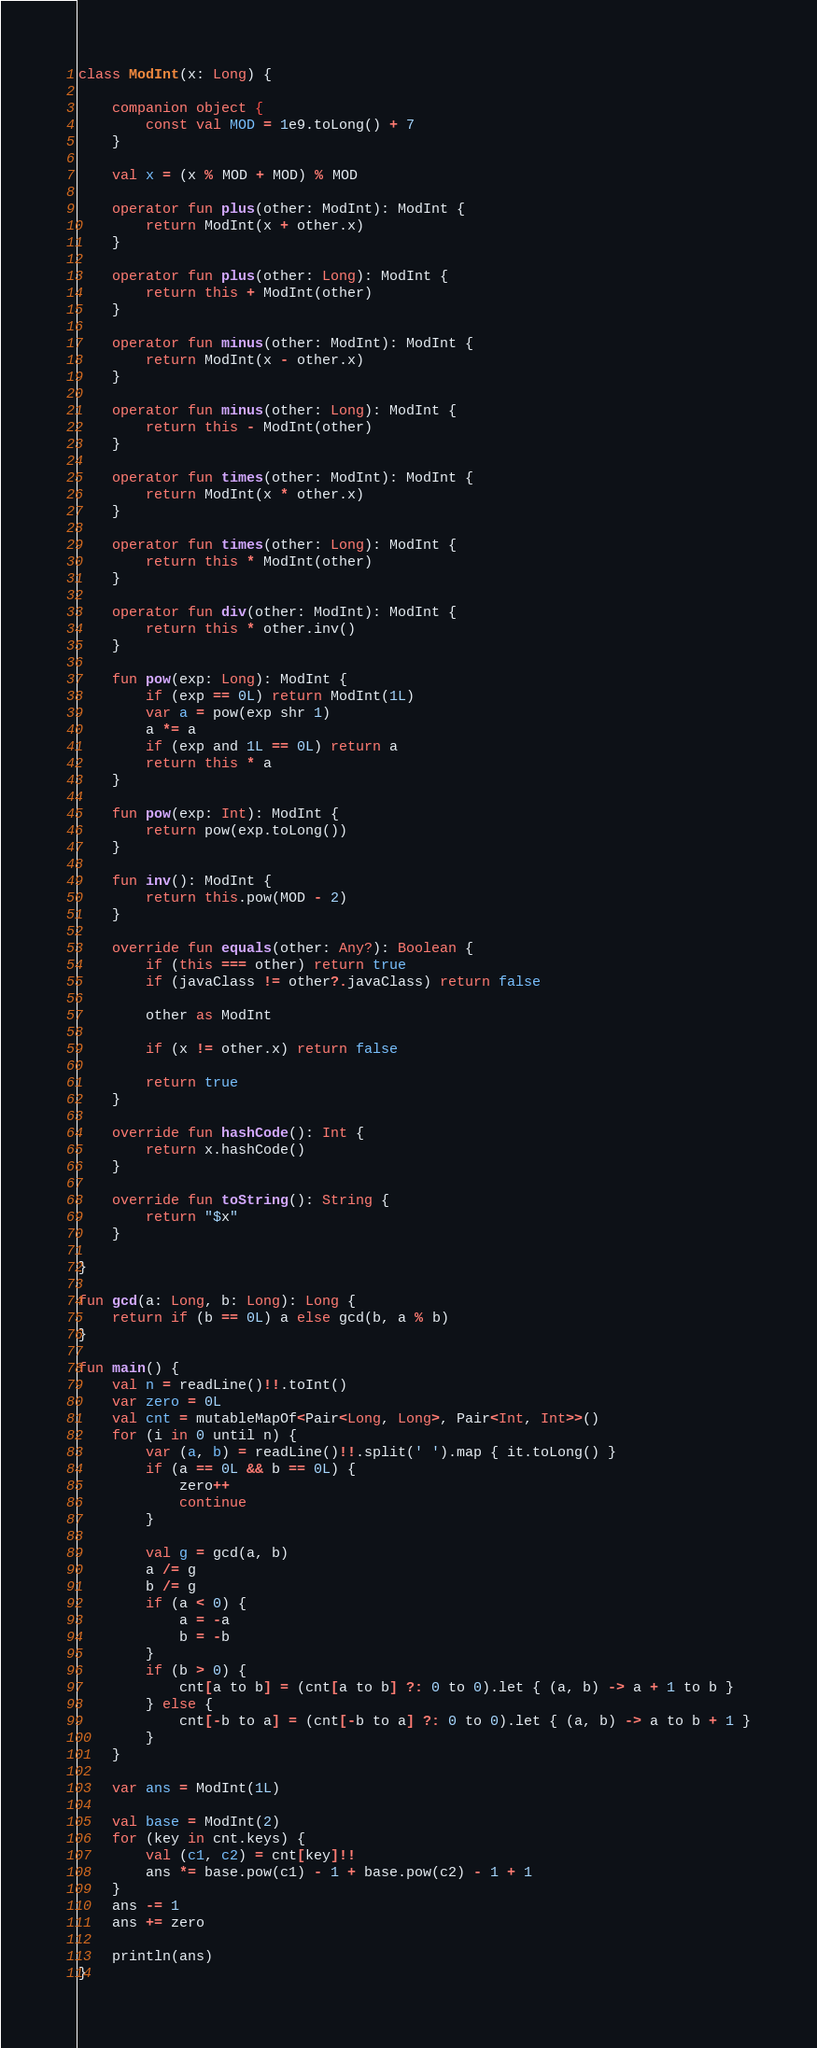Convert code to text. <code><loc_0><loc_0><loc_500><loc_500><_Kotlin_>class ModInt(x: Long) {

    companion object {
        const val MOD = 1e9.toLong() + 7
    }

    val x = (x % MOD + MOD) % MOD

    operator fun plus(other: ModInt): ModInt {
        return ModInt(x + other.x)
    }

    operator fun plus(other: Long): ModInt {
        return this + ModInt(other)
    }

    operator fun minus(other: ModInt): ModInt {
        return ModInt(x - other.x)
    }

    operator fun minus(other: Long): ModInt {
        return this - ModInt(other)
    }

    operator fun times(other: ModInt): ModInt {
        return ModInt(x * other.x)
    }

    operator fun times(other: Long): ModInt {
        return this * ModInt(other)
    }

    operator fun div(other: ModInt): ModInt {
        return this * other.inv()
    }

    fun pow(exp: Long): ModInt {
        if (exp == 0L) return ModInt(1L)
        var a = pow(exp shr 1)
        a *= a
        if (exp and 1L == 0L) return a
        return this * a
    }

    fun pow(exp: Int): ModInt {
        return pow(exp.toLong())
    }

    fun inv(): ModInt {
        return this.pow(MOD - 2)
    }

    override fun equals(other: Any?): Boolean {
        if (this === other) return true
        if (javaClass != other?.javaClass) return false

        other as ModInt

        if (x != other.x) return false

        return true
    }

    override fun hashCode(): Int {
        return x.hashCode()
    }

    override fun toString(): String {
        return "$x"
    }

}

fun gcd(a: Long, b: Long): Long {
    return if (b == 0L) a else gcd(b, a % b)
}

fun main() {
    val n = readLine()!!.toInt()
    var zero = 0L
    val cnt = mutableMapOf<Pair<Long, Long>, Pair<Int, Int>>()
    for (i in 0 until n) {
        var (a, b) = readLine()!!.split(' ').map { it.toLong() }
        if (a == 0L && b == 0L) {
            zero++
            continue
        }

        val g = gcd(a, b)
        a /= g
        b /= g
        if (a < 0) {
            a = -a
            b = -b
        }
        if (b > 0) {
            cnt[a to b] = (cnt[a to b] ?: 0 to 0).let { (a, b) -> a + 1 to b }
        } else {
            cnt[-b to a] = (cnt[-b to a] ?: 0 to 0).let { (a, b) -> a to b + 1 }
        }
    }

    var ans = ModInt(1L)

    val base = ModInt(2)
    for (key in cnt.keys) {
        val (c1, c2) = cnt[key]!!
        ans *= base.pow(c1) - 1 + base.pow(c2) - 1 + 1
    }
    ans -= 1
    ans += zero

    println(ans)
}
</code> 